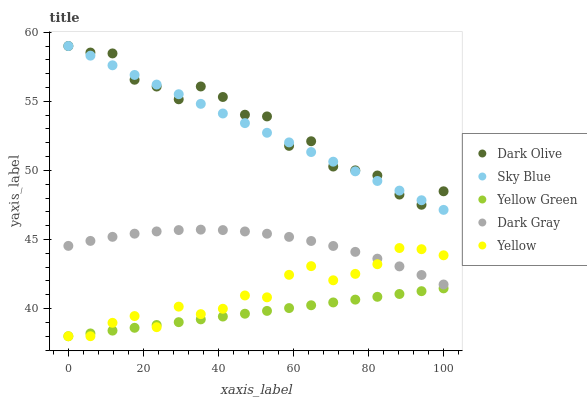Does Yellow Green have the minimum area under the curve?
Answer yes or no. Yes. Does Dark Olive have the maximum area under the curve?
Answer yes or no. Yes. Does Sky Blue have the minimum area under the curve?
Answer yes or no. No. Does Sky Blue have the maximum area under the curve?
Answer yes or no. No. Is Sky Blue the smoothest?
Answer yes or no. Yes. Is Dark Olive the roughest?
Answer yes or no. Yes. Is Dark Olive the smoothest?
Answer yes or no. No. Is Sky Blue the roughest?
Answer yes or no. No. Does Yellow Green have the lowest value?
Answer yes or no. Yes. Does Sky Blue have the lowest value?
Answer yes or no. No. Does Dark Olive have the highest value?
Answer yes or no. Yes. Does Yellow Green have the highest value?
Answer yes or no. No. Is Yellow Green less than Sky Blue?
Answer yes or no. Yes. Is Dark Gray greater than Yellow Green?
Answer yes or no. Yes. Does Yellow intersect Dark Gray?
Answer yes or no. Yes. Is Yellow less than Dark Gray?
Answer yes or no. No. Is Yellow greater than Dark Gray?
Answer yes or no. No. Does Yellow Green intersect Sky Blue?
Answer yes or no. No. 